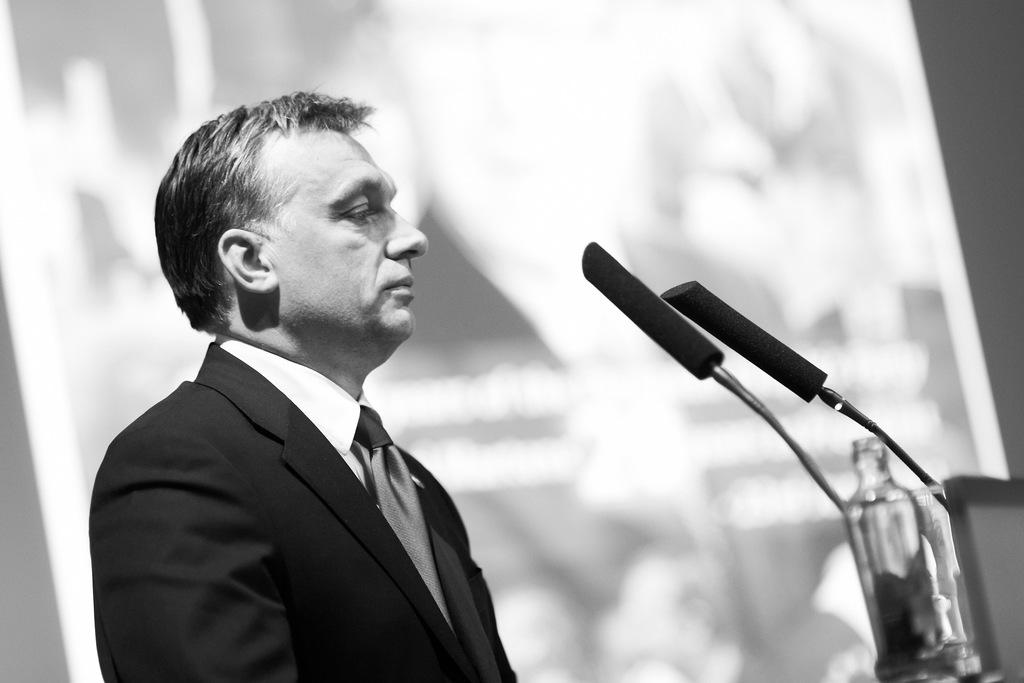What objects can be seen in the image? There are microphones and a bottle in the image. Can you describe the person in the image? There is a person in the image, but no specific details about their appearance or actions are provided. What can be said about the background of the image? The background of the image is blurred. What type of help can be provided by the ear in the image? There is no ear present in the image, so it is not possible to determine what type of help it might provide. 